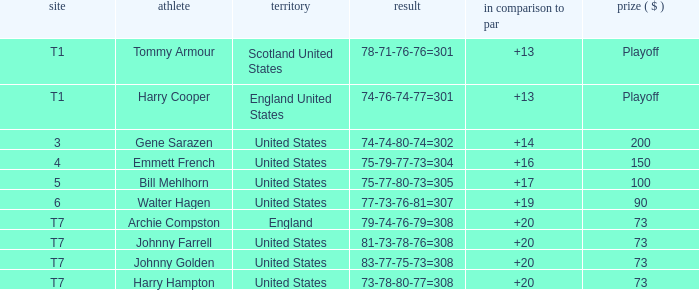What is the score for the United States when Harry Hampton is the player and the money is $73? 73-78-80-77=308. 